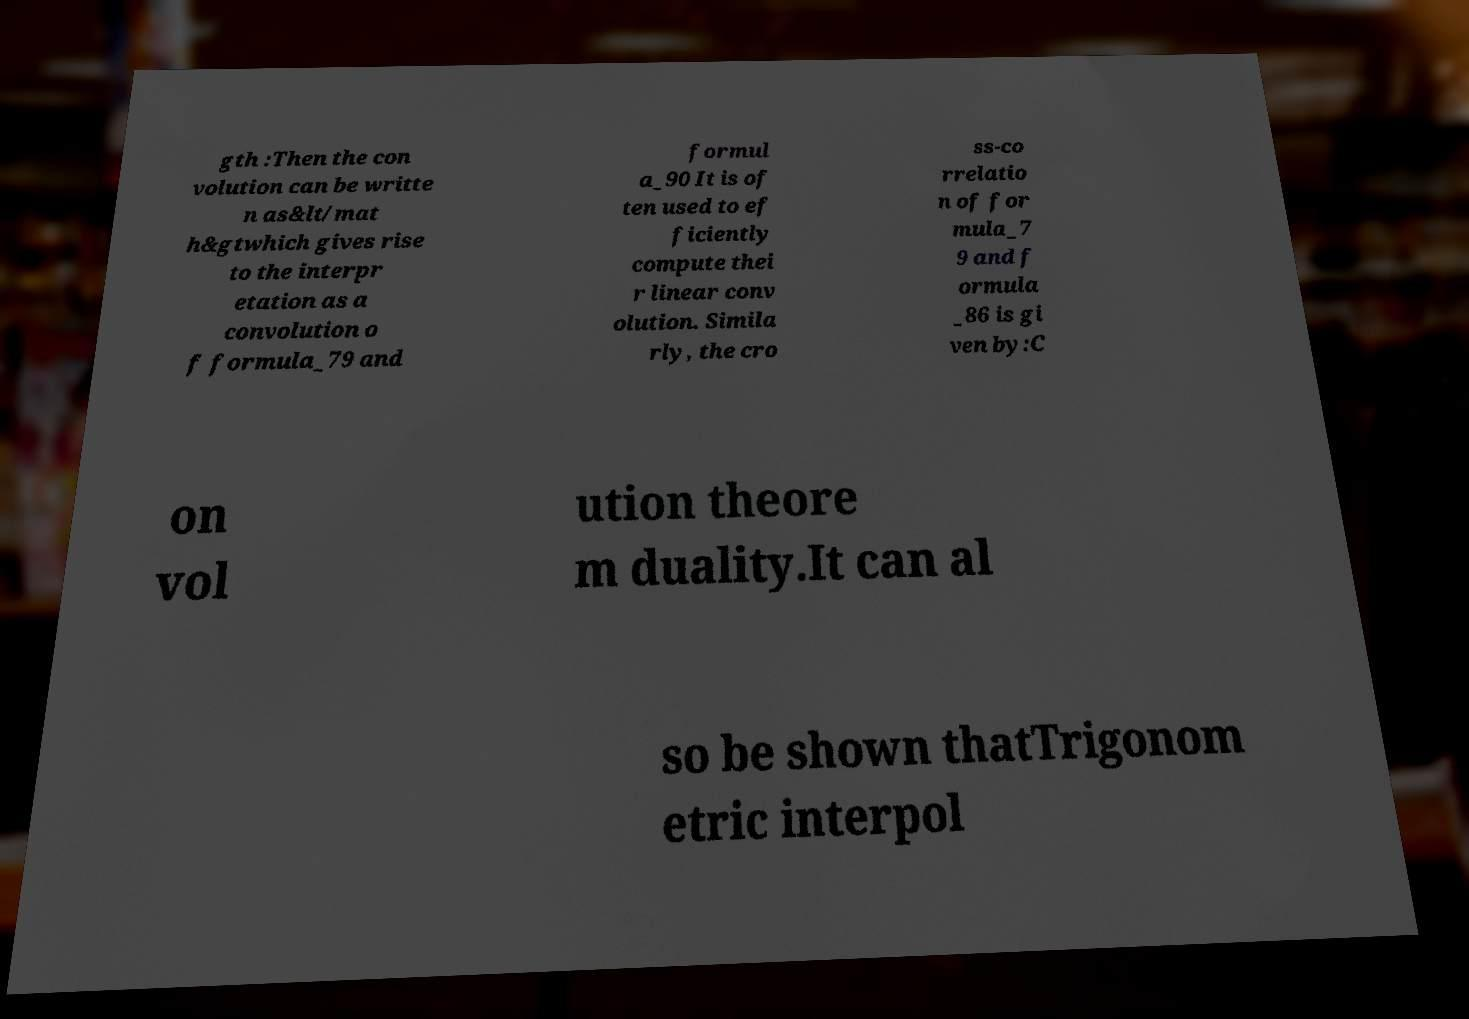Can you read and provide the text displayed in the image?This photo seems to have some interesting text. Can you extract and type it out for me? gth :Then the con volution can be writte n as&lt/mat h&gtwhich gives rise to the interpr etation as a convolution o f formula_79 and formul a_90 It is of ten used to ef ficiently compute thei r linear conv olution. Simila rly, the cro ss-co rrelatio n of for mula_7 9 and f ormula _86 is gi ven by:C on vol ution theore m duality.It can al so be shown thatTrigonom etric interpol 